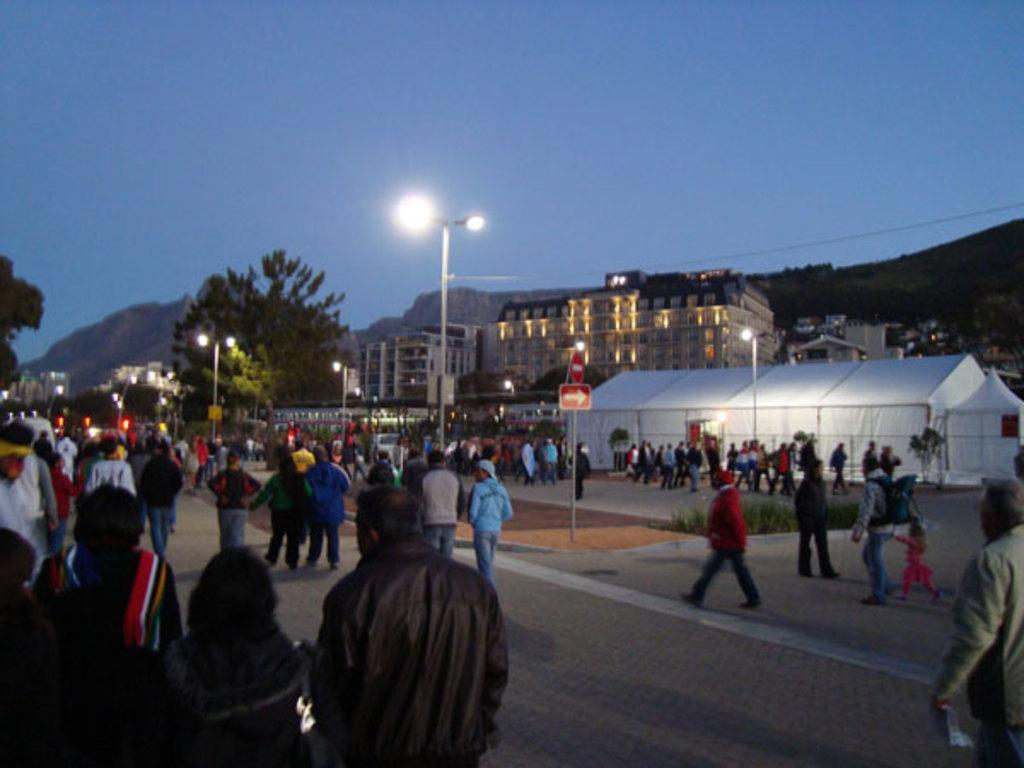What type of location is shown in the image? The image depicts a busy street. How many people can be seen on the street? There are many people on the street. What can be seen in the background of the image? There are buildings, trees, and hills visible in the background. What type of lighting is present on the street? Street lights are beside the road. What additional structure can be seen in the image? There is a tent in the image. What letters are being exchanged between the partners in the image? There is no mention of partners or letters in the image; it depicts a busy street with people, buildings, trees, hills, street lights, and a tent. 